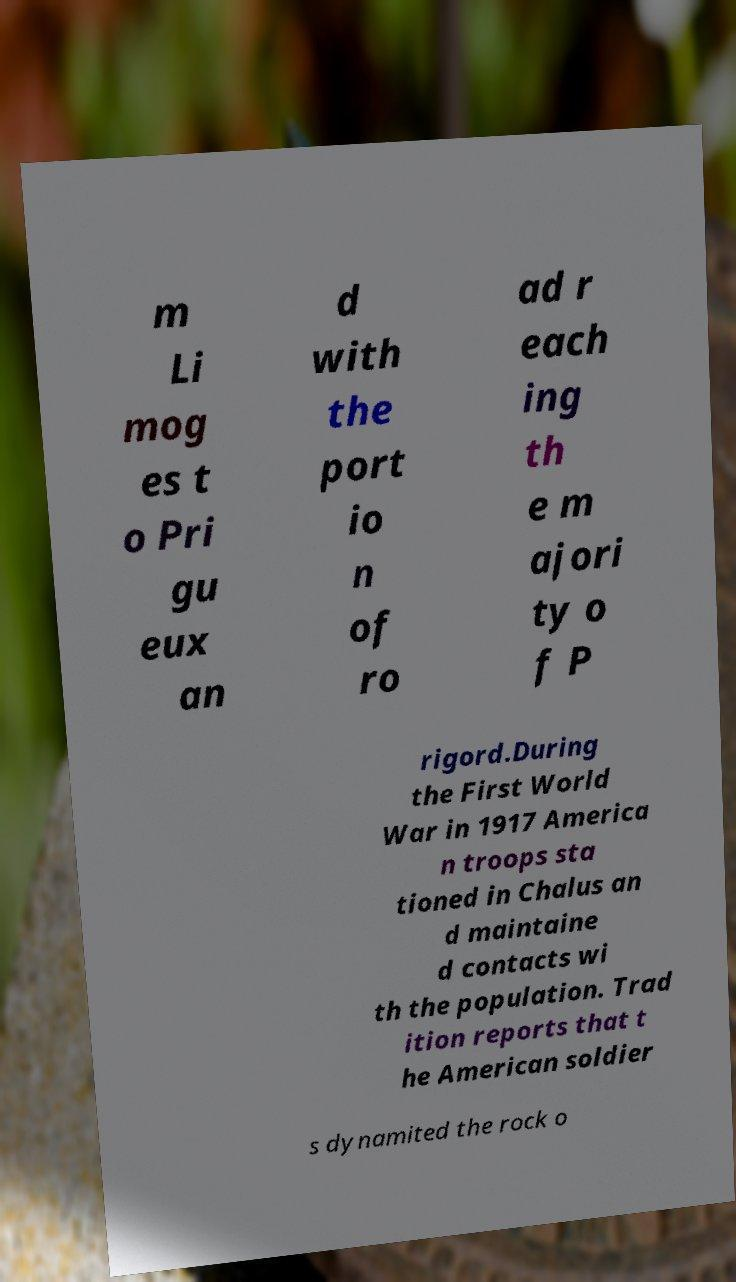What messages or text are displayed in this image? I need them in a readable, typed format. m Li mog es t o Pri gu eux an d with the port io n of ro ad r each ing th e m ajori ty o f P rigord.During the First World War in 1917 America n troops sta tioned in Chalus an d maintaine d contacts wi th the population. Trad ition reports that t he American soldier s dynamited the rock o 